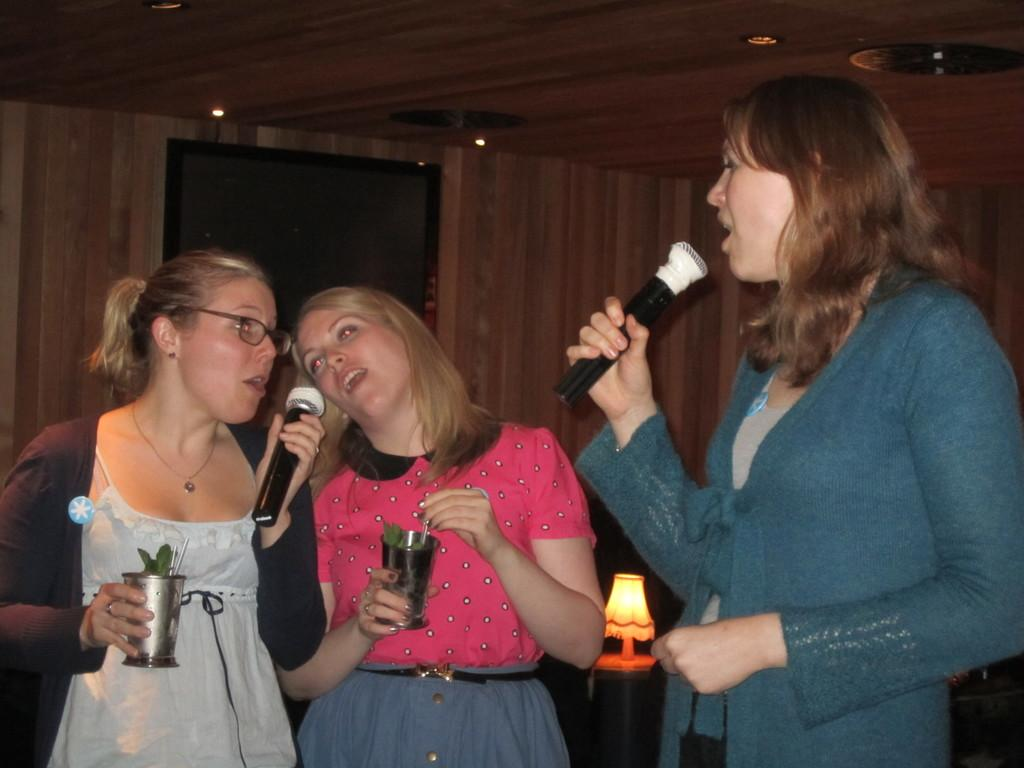How many women are in the image? There are three women in the image. What are the women doing in the image? The women are standing and singing a song. Are the women holding any objects in the image? Yes, two of the women are holding glass tumblers. What can be seen in the background of the image? There is a lamp placed on a table and a door in the background. What color are the kittens playing with the eggs in the image? There are no kittens or eggs present in the image. 